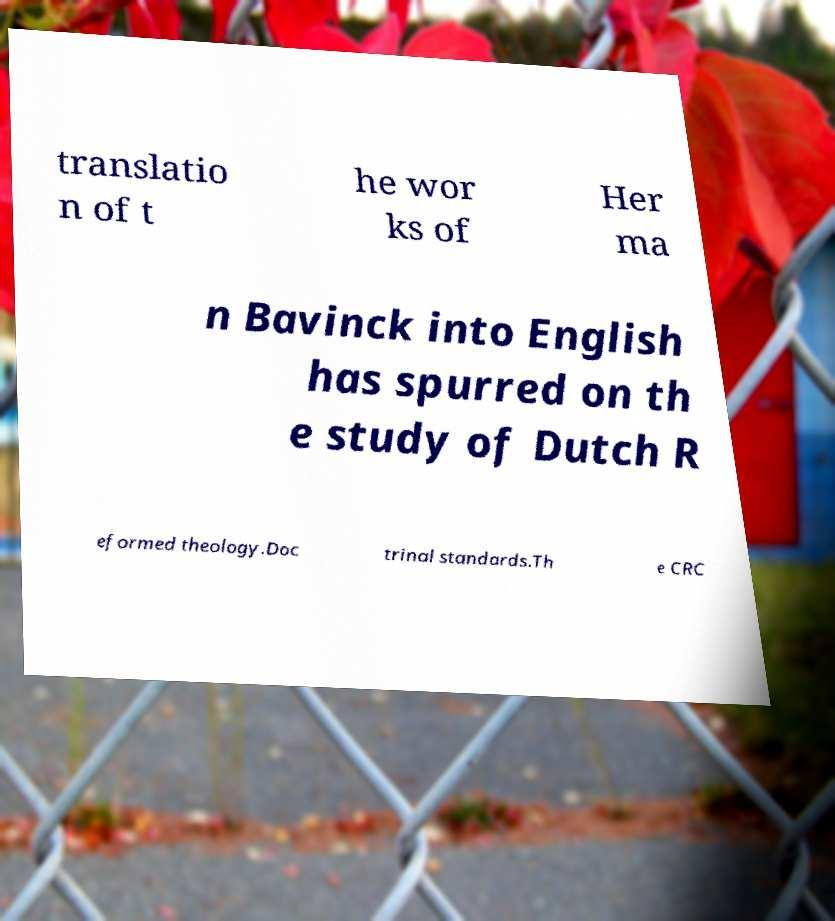There's text embedded in this image that I need extracted. Can you transcribe it verbatim? translatio n of t he wor ks of Her ma n Bavinck into English has spurred on th e study of Dutch R eformed theology.Doc trinal standards.Th e CRC 